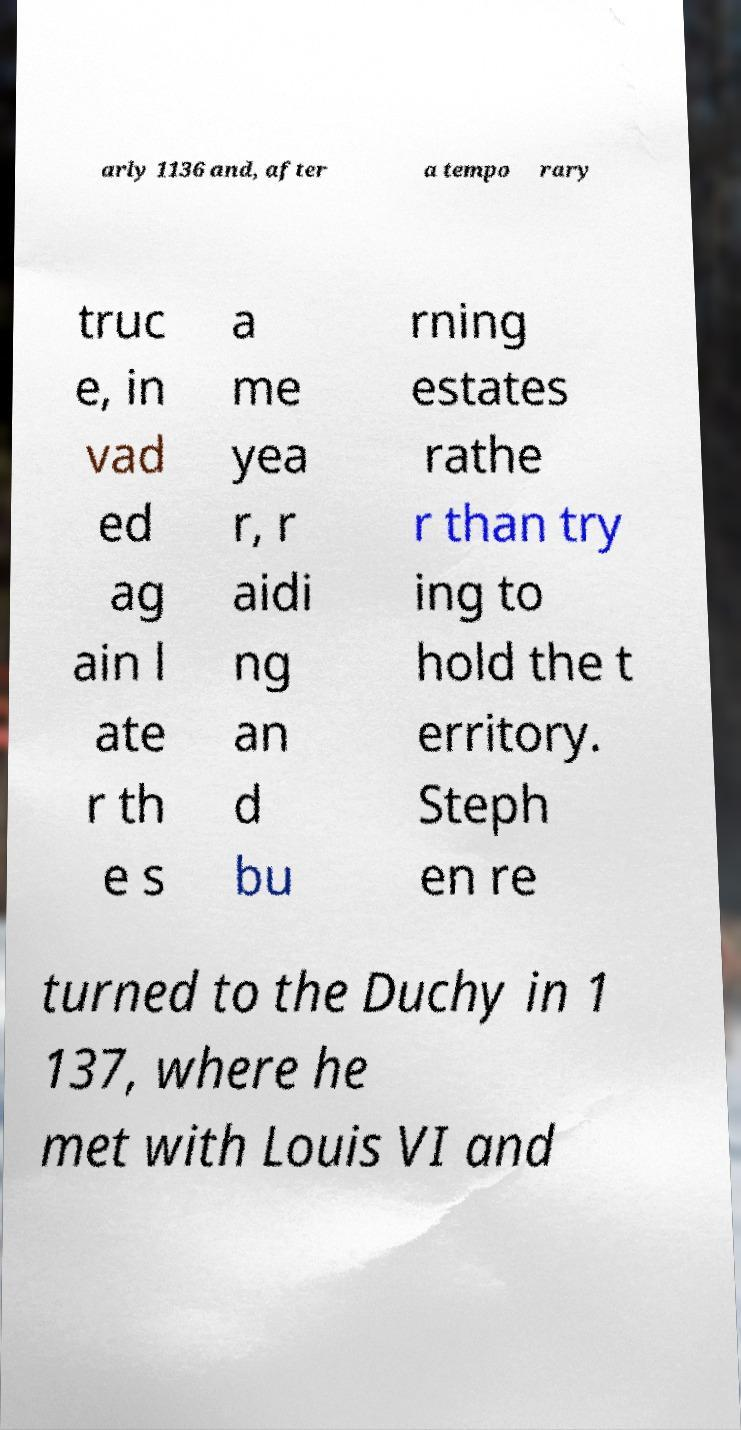Can you accurately transcribe the text from the provided image for me? arly 1136 and, after a tempo rary truc e, in vad ed ag ain l ate r th e s a me yea r, r aidi ng an d bu rning estates rathe r than try ing to hold the t erritory. Steph en re turned to the Duchy in 1 137, where he met with Louis VI and 